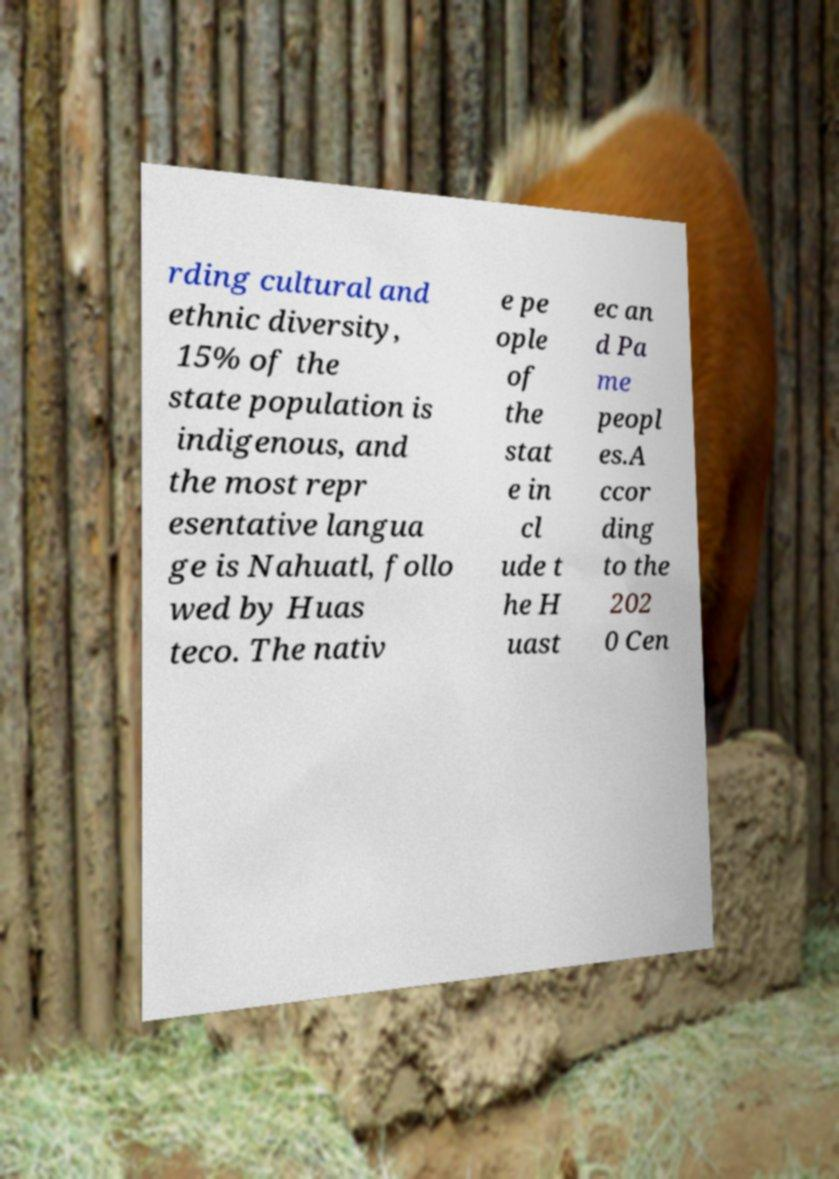Please read and relay the text visible in this image. What does it say? rding cultural and ethnic diversity, 15% of the state population is indigenous, and the most repr esentative langua ge is Nahuatl, follo wed by Huas teco. The nativ e pe ople of the stat e in cl ude t he H uast ec an d Pa me peopl es.A ccor ding to the 202 0 Cen 